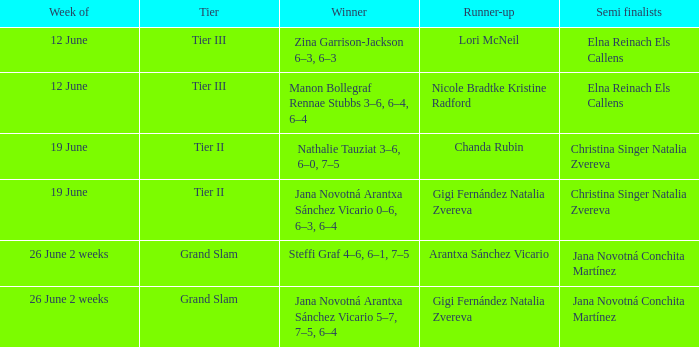Who claimed victory in the week listed as 26 june 2 weeks, when the person finishing just behind was arantxa sánchez vicario? Steffi Graf 4–6, 6–1, 7–5. 